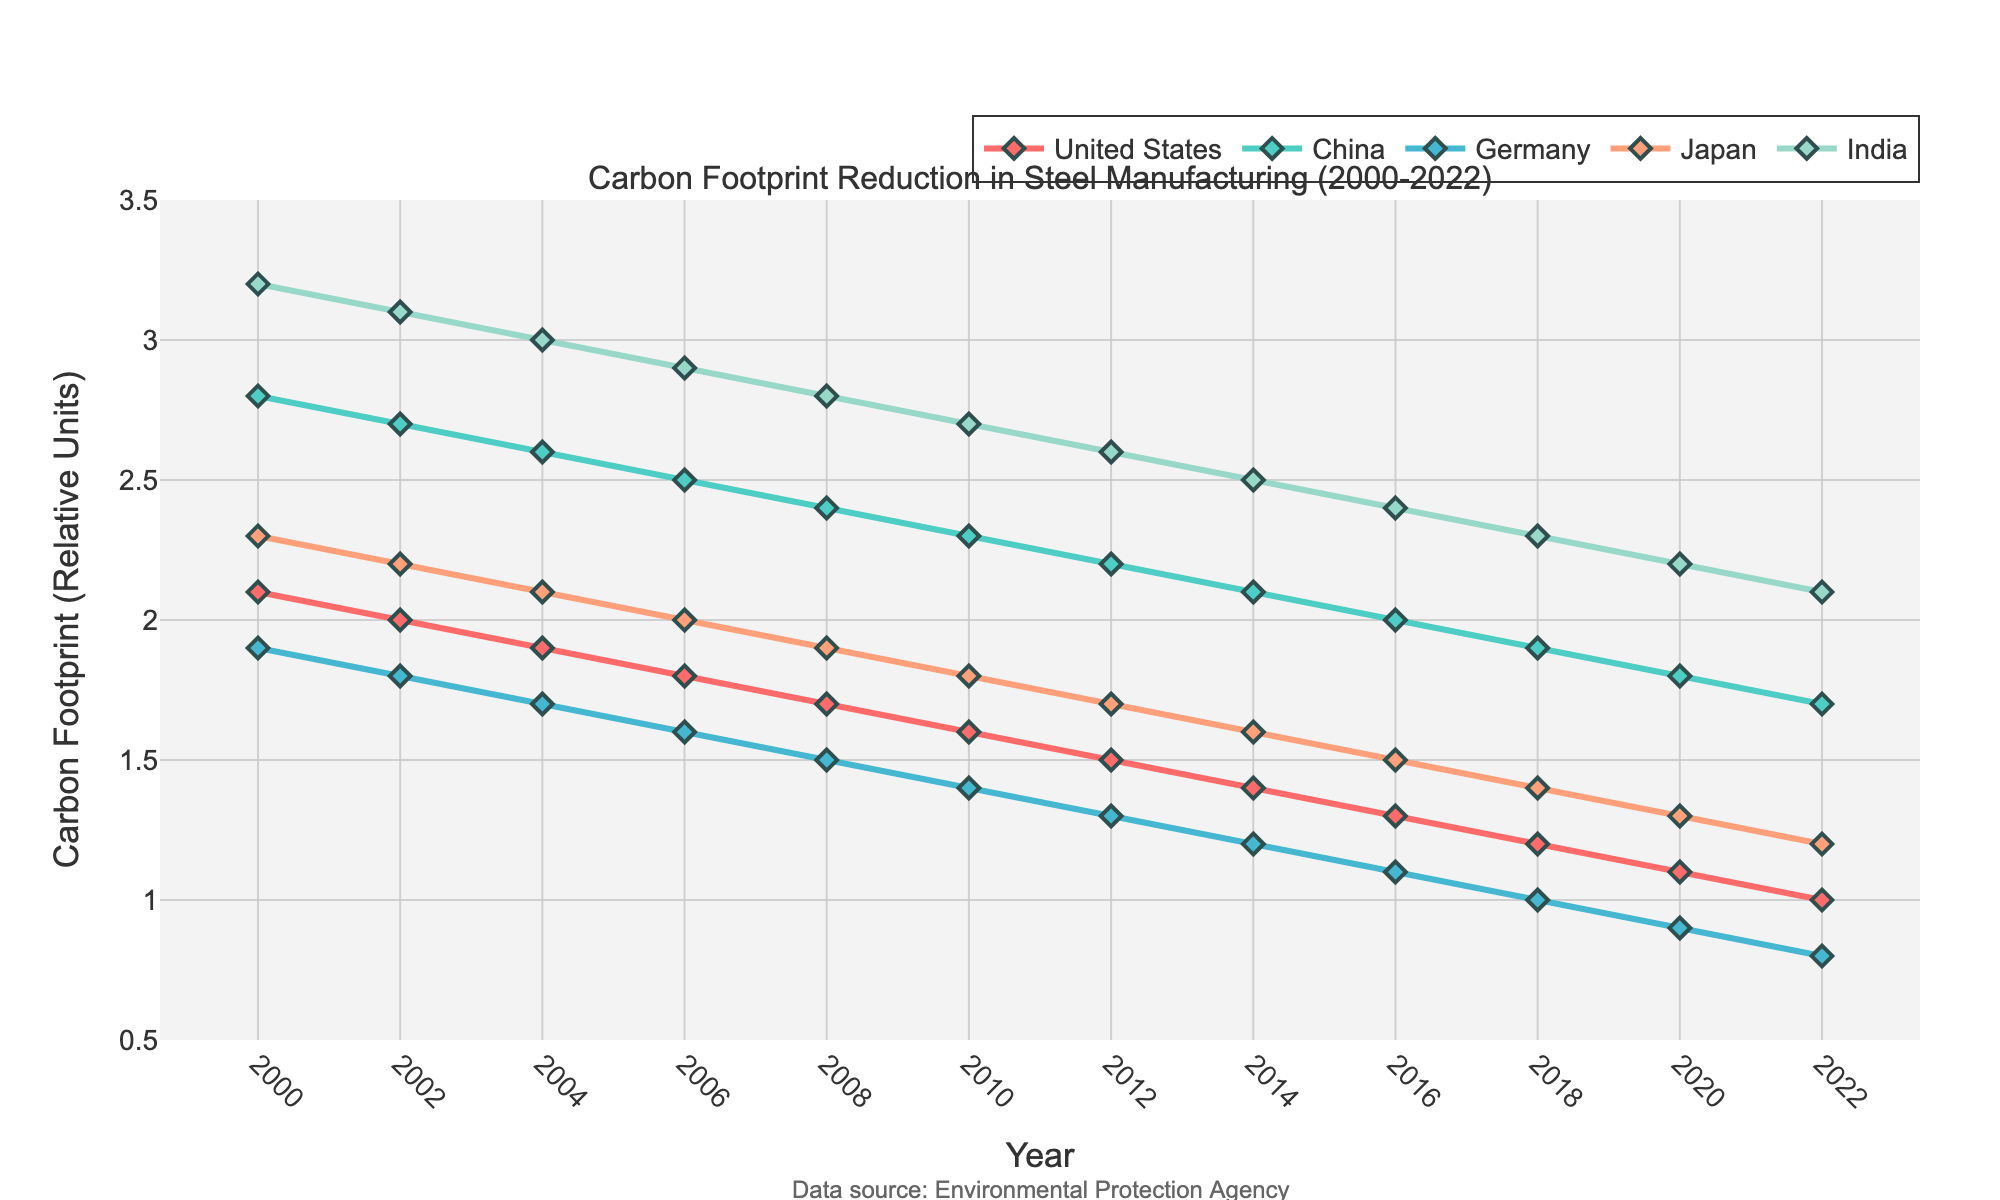What country had the highest carbon footprint in steel manufacturing in 2000? Look at the data points for the year 2000. The highest carbon footprint value belongs to India.
Answer: India Which country shows the most significant reduction in carbon footprint from 2000 to 2022? Compare the carbon footprint values for each country between 2000 and 2022. The United States shows a reduction from 2.1 to 1.0, which is the largest decrease.
Answer: United States How does China's carbon footprint trend compare with Germany's from 2000 to 2022? Look at the trend of China and Germany between 2000 and 2022. Both show a decreasing trend, but China’s carbon footprint remains higher than Germany's throughout the period.
Answer: Both are decreasing, China remains higher Which year did Japan reach a carbon footprint value of 1.5? Identify the data point on Japan’s line where the value reaches 1.5. This occurs in the year 2016.
Answer: 2016 What is the average carbon footprint for India over the period 2000 to 2022? Sum up all the carbon footprint values for India from 2000 to 2022 and divide by the number of years (13). The values are: 3.2, 3.1, 3.0, 2.9, 2.8, 2.7, 2.6, 2.5, 2.4, 2.3, 2.2, 2.1. Summing them gives 33.5, and averaging gives 33.5 / 13 = ~2.58.
Answer: ~2.58 Between 2010 and 2020, which country reduced its carbon footprint the least? Compare the reductions for all countries from 2010 to 2020. China's reduction is from 2.3 to 1.8, which is 0.5 units, the smallest reduction among all countries listed.
Answer: China What is the relative position of the United States' carbon footprint in 2010 compared to other countries? Identify the 2010 values for each country and compare. In 2010: United States (1.6), China (2.3), Germany (1.4), Japan (1.8), India (2.7). The United States is the second-lowest after Germany.
Answer: Second-lowest What was the carbon footprint of Germany and India in 2006, and what is their difference? Check the 2006 data points for Germany and India. Germany: 1.6, India: 2.9. The difference is 2.9 - 1.6 = 1.3.
Answer: 1.3 Which country had the lowest carbon footprint in 2022 and what is its value? Look at the 2022 data points and identify the lowest value. Germany has the lowest value at 0.8.
Answer: Germany, 0.8 